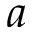<formula> <loc_0><loc_0><loc_500><loc_500>a</formula> 